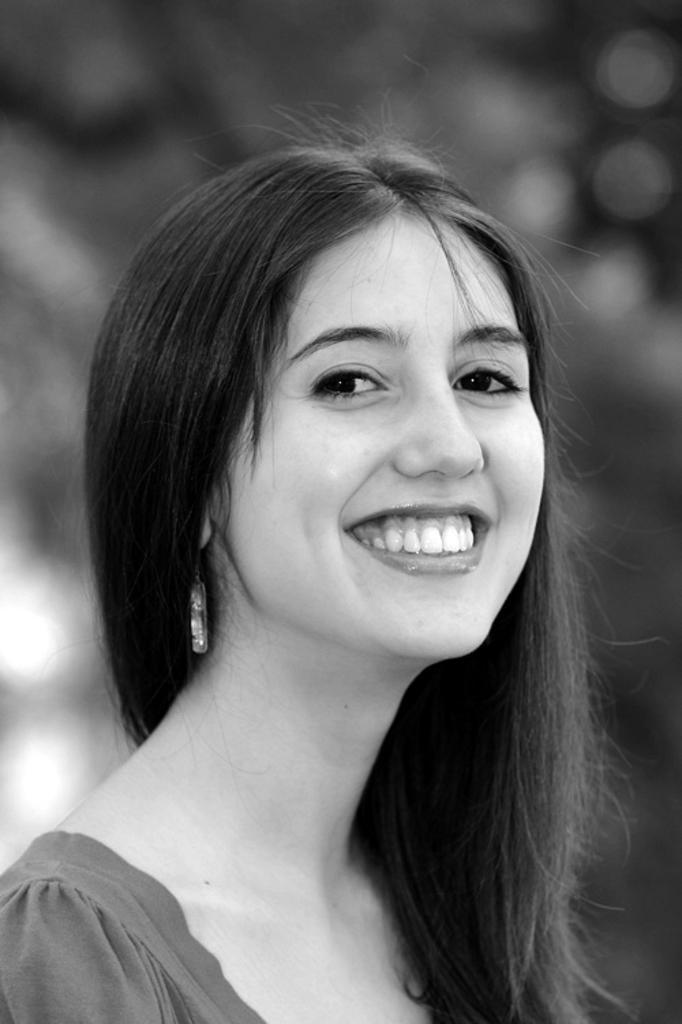Describe this image in one or two sentences. This image consists of a woman and the background is not clear. This image is taken may be during a day. 